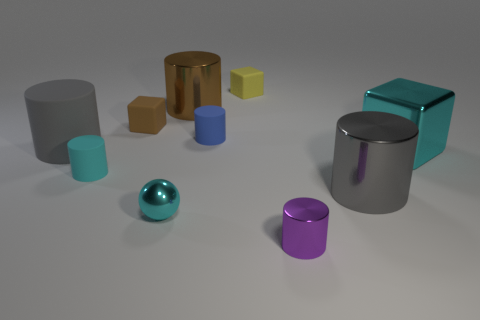Subtract all small blocks. How many blocks are left? 1 Subtract all purple cylinders. How many cylinders are left? 5 Subtract all blocks. How many objects are left? 7 Subtract 4 cylinders. How many cylinders are left? 2 Subtract all red blocks. Subtract all cyan spheres. How many blocks are left? 3 Subtract all cyan cubes. How many yellow spheres are left? 0 Subtract all tiny shiny objects. Subtract all tiny brown rubber blocks. How many objects are left? 7 Add 5 small cyan objects. How many small cyan objects are left? 7 Add 7 small blue metallic cylinders. How many small blue metallic cylinders exist? 7 Subtract 0 blue cubes. How many objects are left? 10 